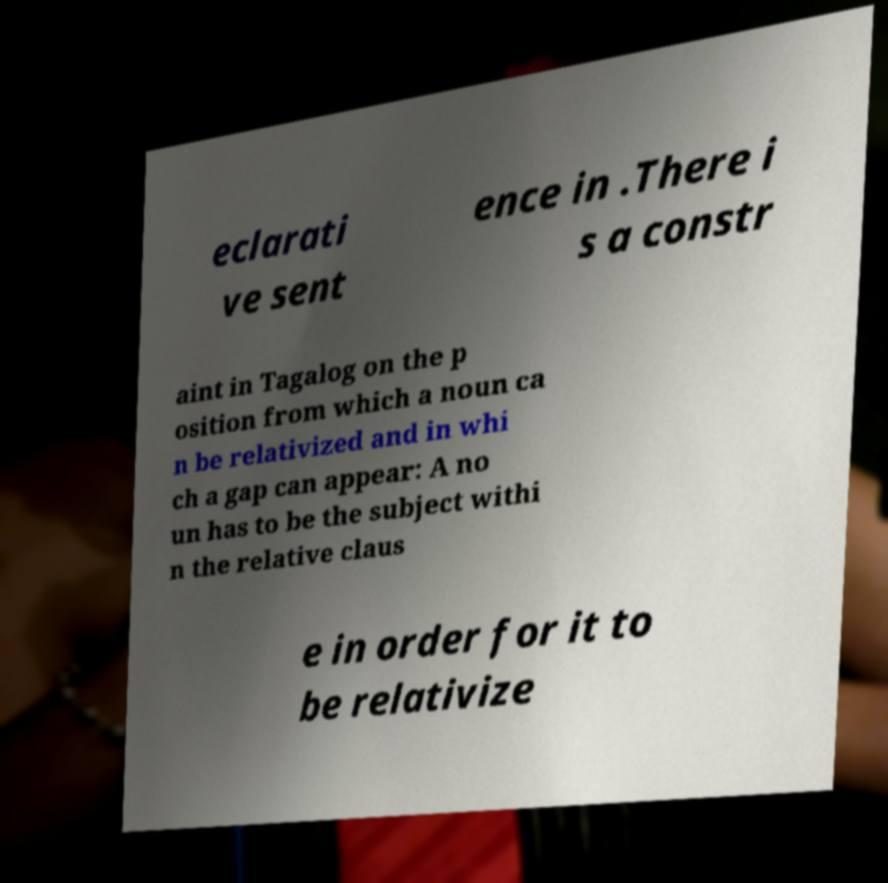Can you read and provide the text displayed in the image?This photo seems to have some interesting text. Can you extract and type it out for me? eclarati ve sent ence in .There i s a constr aint in Tagalog on the p osition from which a noun ca n be relativized and in whi ch a gap can appear: A no un has to be the subject withi n the relative claus e in order for it to be relativize 